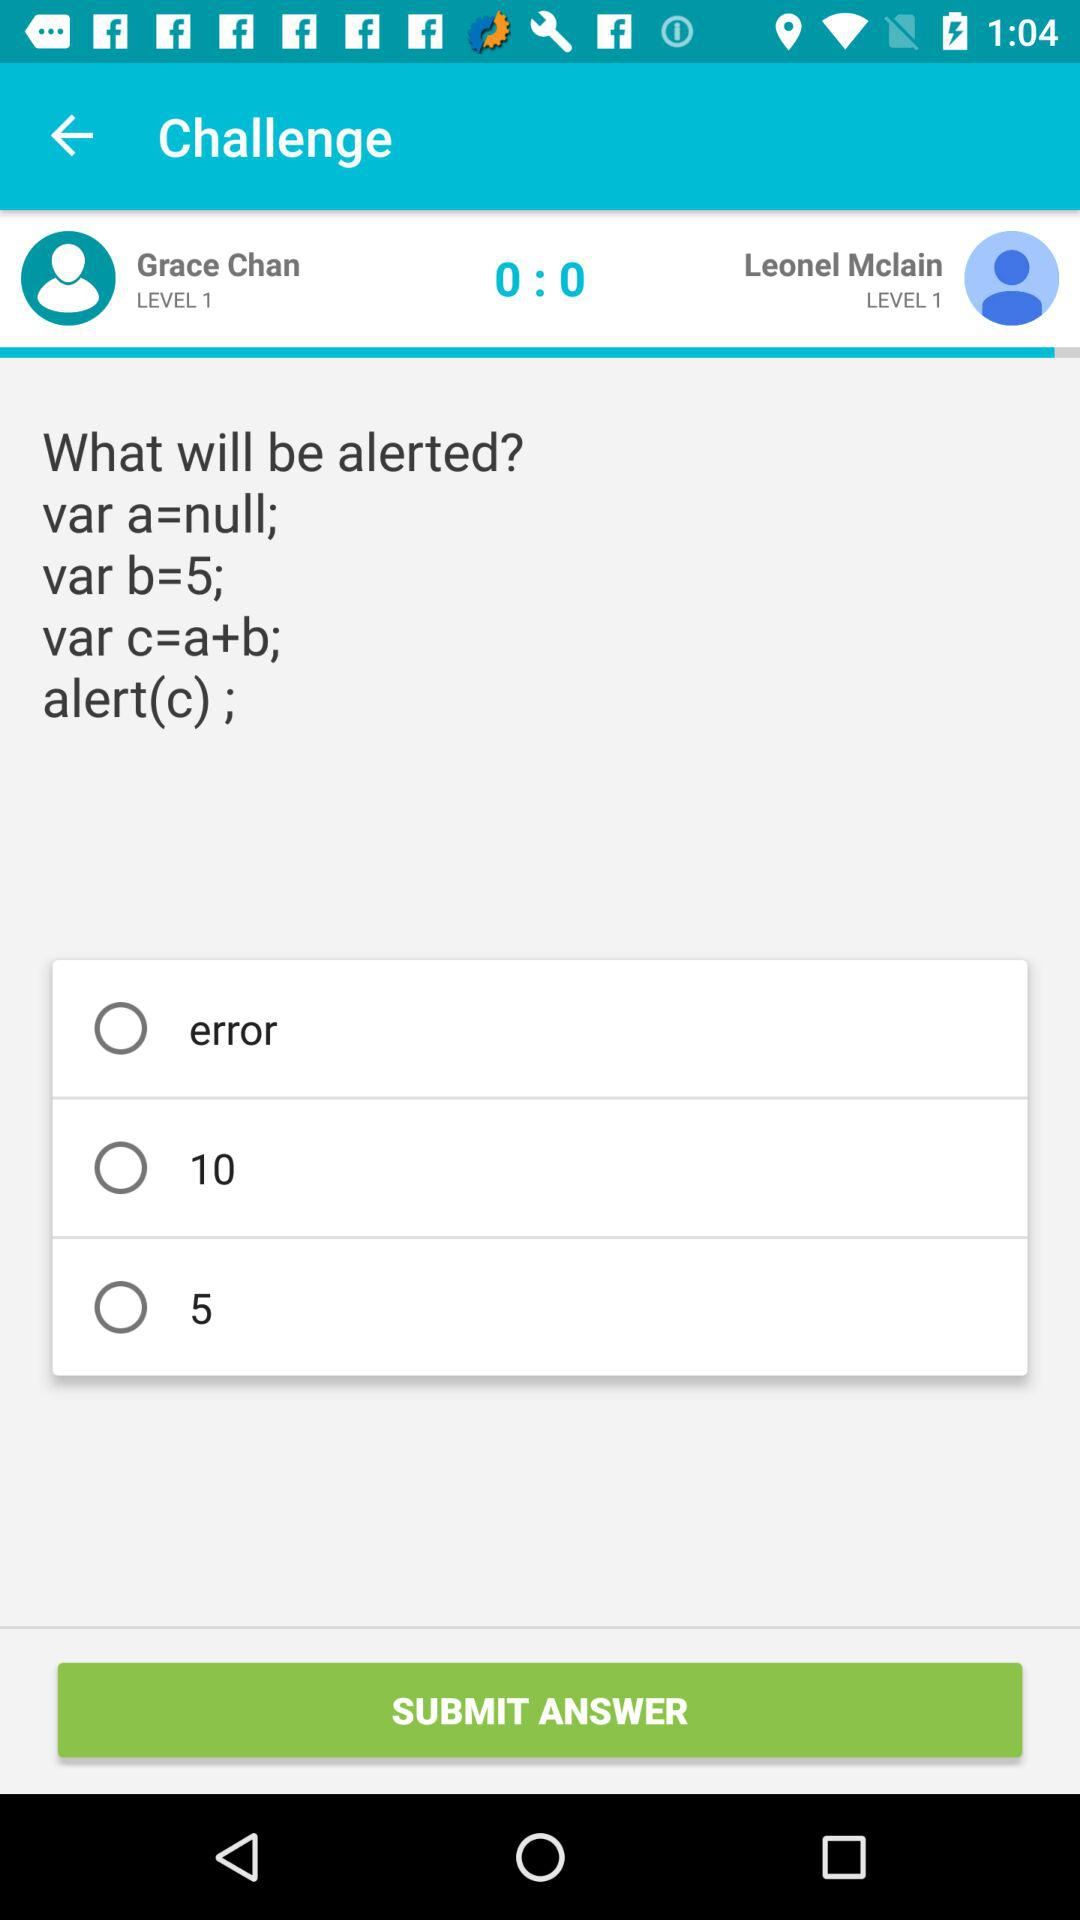What is the value of var a? The value of var a is null. 